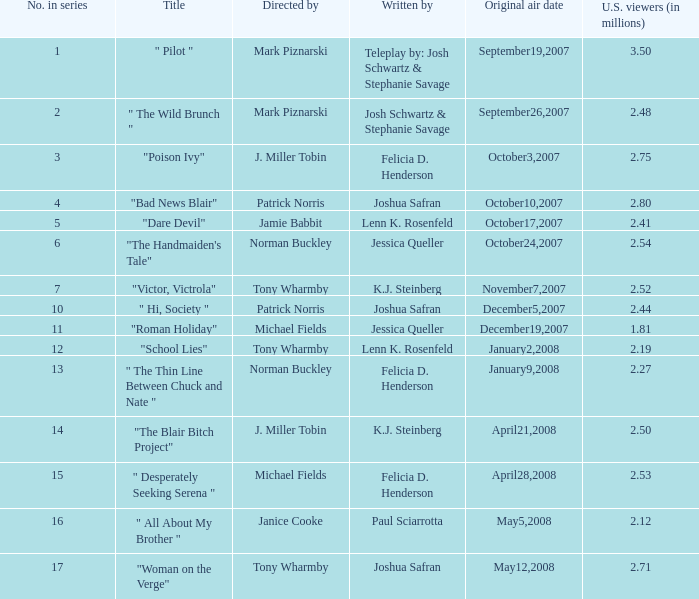What is the original air date when "poison ivy" is the title? October3,2007. 